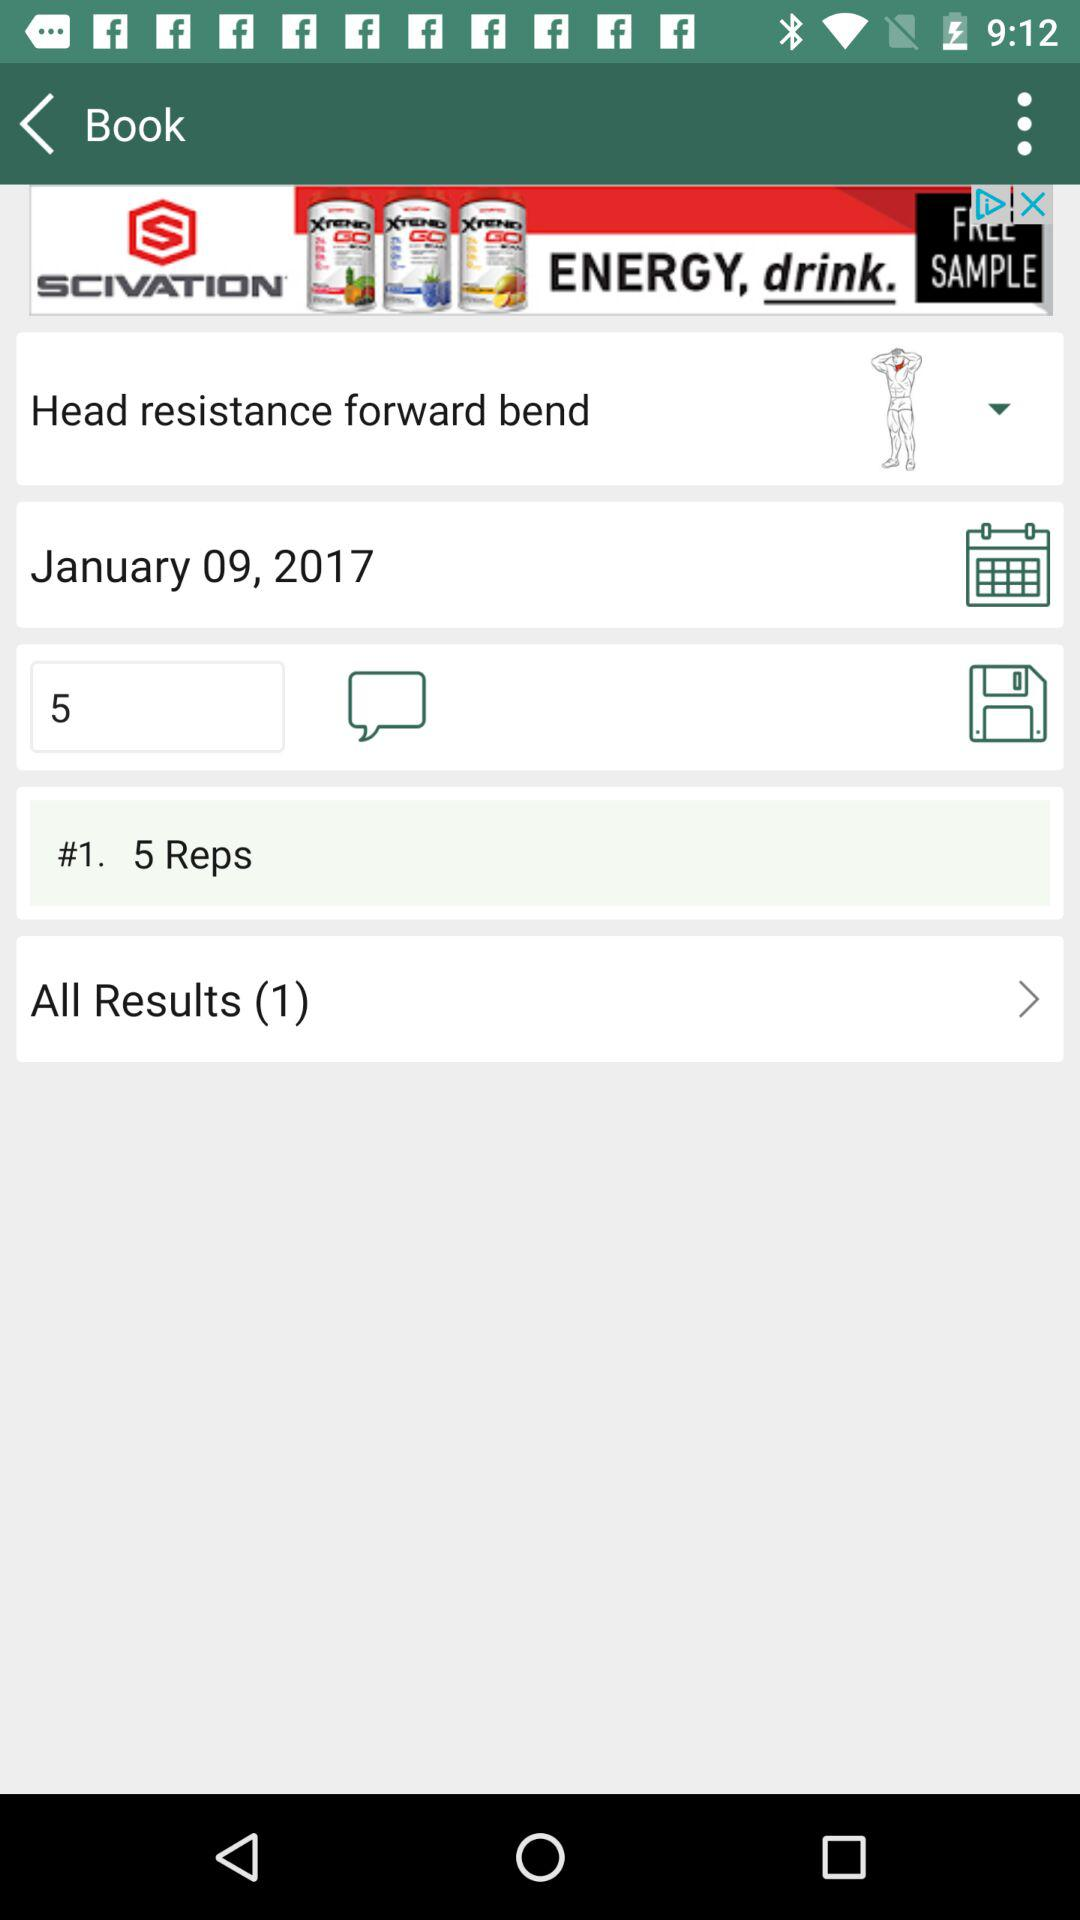What is the date? The date is January 9, 2017. 